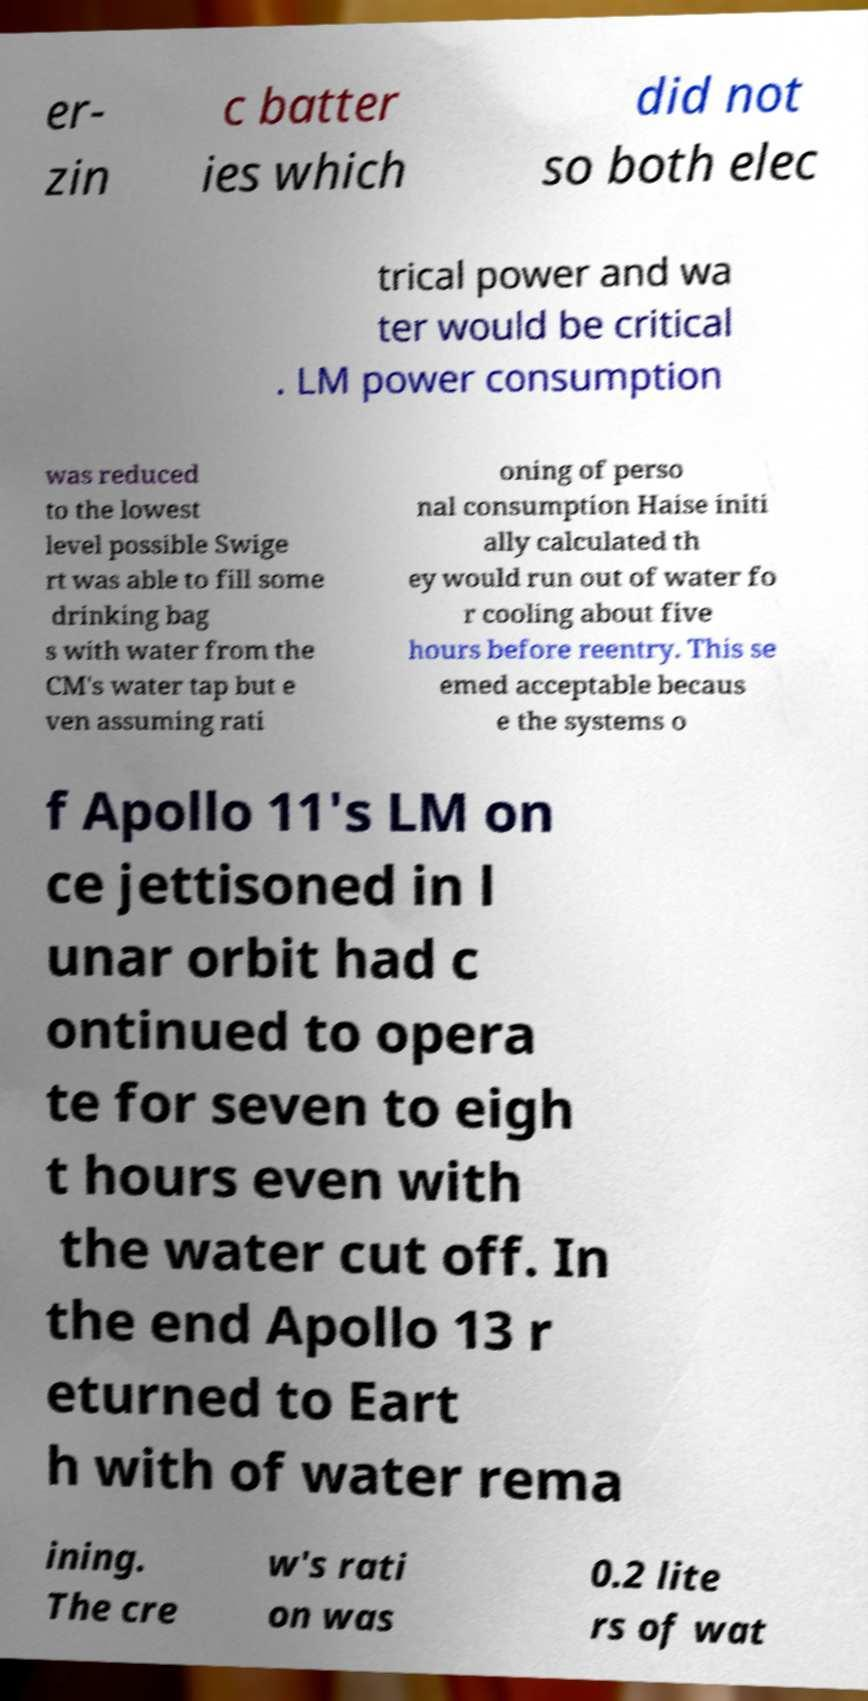I need the written content from this picture converted into text. Can you do that? er- zin c batter ies which did not so both elec trical power and wa ter would be critical . LM power consumption was reduced to the lowest level possible Swige rt was able to fill some drinking bag s with water from the CM's water tap but e ven assuming rati oning of perso nal consumption Haise initi ally calculated th ey would run out of water fo r cooling about five hours before reentry. This se emed acceptable becaus e the systems o f Apollo 11's LM on ce jettisoned in l unar orbit had c ontinued to opera te for seven to eigh t hours even with the water cut off. In the end Apollo 13 r eturned to Eart h with of water rema ining. The cre w's rati on was 0.2 lite rs of wat 